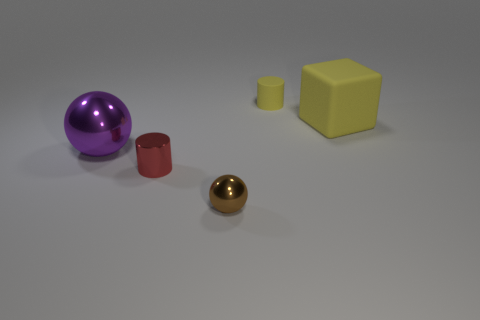What number of tiny brown balls have the same material as the red thing?
Make the answer very short. 1. Is the number of yellow objects that are on the right side of the yellow matte cylinder greater than the number of small purple cylinders?
Offer a terse response. Yes. There is a object that is the same color as the large cube; what size is it?
Your response must be concise. Small. Is there a tiny thing that has the same shape as the large purple metallic thing?
Ensure brevity in your answer.  Yes. What number of things are either brown rubber cylinders or large purple things?
Offer a very short reply. 1. What number of big yellow matte cubes are to the right of the tiny thing behind the shiny ball that is behind the brown ball?
Ensure brevity in your answer.  1. What material is the other tiny thing that is the same shape as the red thing?
Your response must be concise. Rubber. There is a object that is both to the left of the small brown thing and right of the large metal thing; what material is it?
Give a very brief answer. Metal. Is the number of small yellow cylinders to the left of the large purple metallic object less than the number of big purple metal spheres that are behind the shiny cylinder?
Provide a short and direct response. Yes. How many other objects are there of the same size as the metal cylinder?
Offer a very short reply. 2. 